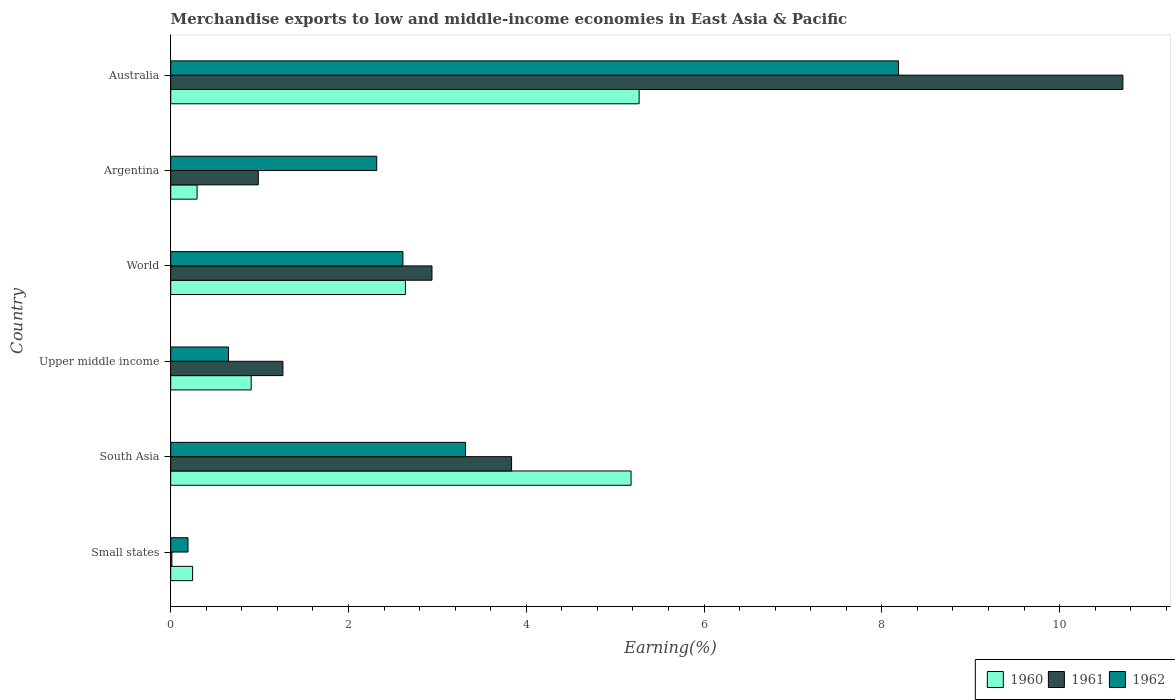How many different coloured bars are there?
Give a very brief answer. 3. How many groups of bars are there?
Offer a terse response. 6. Are the number of bars per tick equal to the number of legend labels?
Give a very brief answer. Yes. How many bars are there on the 2nd tick from the top?
Make the answer very short. 3. How many bars are there on the 3rd tick from the bottom?
Offer a terse response. 3. What is the label of the 6th group of bars from the top?
Provide a succinct answer. Small states. In how many cases, is the number of bars for a given country not equal to the number of legend labels?
Your answer should be very brief. 0. What is the percentage of amount earned from merchandise exports in 1961 in Small states?
Keep it short and to the point. 0.01. Across all countries, what is the maximum percentage of amount earned from merchandise exports in 1962?
Offer a very short reply. 8.19. Across all countries, what is the minimum percentage of amount earned from merchandise exports in 1962?
Ensure brevity in your answer.  0.19. In which country was the percentage of amount earned from merchandise exports in 1961 maximum?
Provide a succinct answer. Australia. In which country was the percentage of amount earned from merchandise exports in 1960 minimum?
Offer a very short reply. Small states. What is the total percentage of amount earned from merchandise exports in 1961 in the graph?
Your answer should be compact. 19.75. What is the difference between the percentage of amount earned from merchandise exports in 1961 in South Asia and that in Upper middle income?
Keep it short and to the point. 2.57. What is the difference between the percentage of amount earned from merchandise exports in 1961 in Upper middle income and the percentage of amount earned from merchandise exports in 1962 in Australia?
Your response must be concise. -6.93. What is the average percentage of amount earned from merchandise exports in 1961 per country?
Make the answer very short. 3.29. What is the difference between the percentage of amount earned from merchandise exports in 1960 and percentage of amount earned from merchandise exports in 1962 in Australia?
Your response must be concise. -2.92. In how many countries, is the percentage of amount earned from merchandise exports in 1961 greater than 5.6 %?
Make the answer very short. 1. What is the ratio of the percentage of amount earned from merchandise exports in 1960 in Argentina to that in Upper middle income?
Your answer should be compact. 0.33. Is the percentage of amount earned from merchandise exports in 1961 in South Asia less than that in World?
Ensure brevity in your answer.  No. What is the difference between the highest and the second highest percentage of amount earned from merchandise exports in 1962?
Provide a short and direct response. 4.87. What is the difference between the highest and the lowest percentage of amount earned from merchandise exports in 1961?
Keep it short and to the point. 10.7. Is it the case that in every country, the sum of the percentage of amount earned from merchandise exports in 1961 and percentage of amount earned from merchandise exports in 1960 is greater than the percentage of amount earned from merchandise exports in 1962?
Give a very brief answer. No. What is the difference between two consecutive major ticks on the X-axis?
Make the answer very short. 2. Where does the legend appear in the graph?
Make the answer very short. Bottom right. How many legend labels are there?
Provide a succinct answer. 3. How are the legend labels stacked?
Make the answer very short. Horizontal. What is the title of the graph?
Provide a short and direct response. Merchandise exports to low and middle-income economies in East Asia & Pacific. What is the label or title of the X-axis?
Provide a succinct answer. Earning(%). What is the label or title of the Y-axis?
Keep it short and to the point. Country. What is the Earning(%) of 1960 in Small states?
Give a very brief answer. 0.25. What is the Earning(%) of 1961 in Small states?
Provide a succinct answer. 0.01. What is the Earning(%) of 1962 in Small states?
Ensure brevity in your answer.  0.19. What is the Earning(%) of 1960 in South Asia?
Offer a terse response. 5.18. What is the Earning(%) of 1961 in South Asia?
Your answer should be compact. 3.83. What is the Earning(%) in 1962 in South Asia?
Provide a succinct answer. 3.32. What is the Earning(%) in 1960 in Upper middle income?
Your answer should be compact. 0.91. What is the Earning(%) of 1961 in Upper middle income?
Make the answer very short. 1.26. What is the Earning(%) in 1962 in Upper middle income?
Keep it short and to the point. 0.65. What is the Earning(%) of 1960 in World?
Keep it short and to the point. 2.64. What is the Earning(%) of 1961 in World?
Your answer should be very brief. 2.94. What is the Earning(%) in 1962 in World?
Keep it short and to the point. 2.61. What is the Earning(%) of 1960 in Argentina?
Provide a succinct answer. 0.3. What is the Earning(%) of 1961 in Argentina?
Provide a succinct answer. 0.99. What is the Earning(%) in 1962 in Argentina?
Offer a very short reply. 2.32. What is the Earning(%) of 1960 in Australia?
Your answer should be compact. 5.27. What is the Earning(%) in 1961 in Australia?
Offer a terse response. 10.71. What is the Earning(%) of 1962 in Australia?
Keep it short and to the point. 8.19. Across all countries, what is the maximum Earning(%) in 1960?
Ensure brevity in your answer.  5.27. Across all countries, what is the maximum Earning(%) of 1961?
Provide a short and direct response. 10.71. Across all countries, what is the maximum Earning(%) in 1962?
Your response must be concise. 8.19. Across all countries, what is the minimum Earning(%) in 1960?
Your answer should be compact. 0.25. Across all countries, what is the minimum Earning(%) in 1961?
Ensure brevity in your answer.  0.01. Across all countries, what is the minimum Earning(%) in 1962?
Your answer should be very brief. 0.19. What is the total Earning(%) of 1960 in the graph?
Provide a succinct answer. 14.54. What is the total Earning(%) in 1961 in the graph?
Offer a terse response. 19.75. What is the total Earning(%) of 1962 in the graph?
Your answer should be compact. 17.28. What is the difference between the Earning(%) in 1960 in Small states and that in South Asia?
Keep it short and to the point. -4.93. What is the difference between the Earning(%) of 1961 in Small states and that in South Asia?
Provide a succinct answer. -3.82. What is the difference between the Earning(%) of 1962 in Small states and that in South Asia?
Provide a short and direct response. -3.12. What is the difference between the Earning(%) in 1960 in Small states and that in Upper middle income?
Provide a short and direct response. -0.66. What is the difference between the Earning(%) in 1961 in Small states and that in Upper middle income?
Provide a succinct answer. -1.25. What is the difference between the Earning(%) in 1962 in Small states and that in Upper middle income?
Make the answer very short. -0.46. What is the difference between the Earning(%) of 1960 in Small states and that in World?
Offer a very short reply. -2.39. What is the difference between the Earning(%) in 1961 in Small states and that in World?
Your response must be concise. -2.93. What is the difference between the Earning(%) of 1962 in Small states and that in World?
Provide a succinct answer. -2.42. What is the difference between the Earning(%) of 1960 in Small states and that in Argentina?
Your answer should be very brief. -0.05. What is the difference between the Earning(%) in 1961 in Small states and that in Argentina?
Offer a terse response. -0.97. What is the difference between the Earning(%) of 1962 in Small states and that in Argentina?
Provide a succinct answer. -2.12. What is the difference between the Earning(%) in 1960 in Small states and that in Australia?
Offer a very short reply. -5.02. What is the difference between the Earning(%) in 1961 in Small states and that in Australia?
Give a very brief answer. -10.7. What is the difference between the Earning(%) of 1962 in Small states and that in Australia?
Ensure brevity in your answer.  -7.99. What is the difference between the Earning(%) in 1960 in South Asia and that in Upper middle income?
Keep it short and to the point. 4.27. What is the difference between the Earning(%) of 1961 in South Asia and that in Upper middle income?
Offer a very short reply. 2.57. What is the difference between the Earning(%) of 1962 in South Asia and that in Upper middle income?
Keep it short and to the point. 2.67. What is the difference between the Earning(%) of 1960 in South Asia and that in World?
Keep it short and to the point. 2.54. What is the difference between the Earning(%) in 1961 in South Asia and that in World?
Make the answer very short. 0.9. What is the difference between the Earning(%) in 1962 in South Asia and that in World?
Offer a terse response. 0.7. What is the difference between the Earning(%) of 1960 in South Asia and that in Argentina?
Your answer should be very brief. 4.88. What is the difference between the Earning(%) of 1961 in South Asia and that in Argentina?
Provide a succinct answer. 2.85. What is the difference between the Earning(%) in 1962 in South Asia and that in Argentina?
Your answer should be very brief. 1. What is the difference between the Earning(%) of 1960 in South Asia and that in Australia?
Give a very brief answer. -0.09. What is the difference between the Earning(%) in 1961 in South Asia and that in Australia?
Keep it short and to the point. -6.88. What is the difference between the Earning(%) of 1962 in South Asia and that in Australia?
Offer a terse response. -4.87. What is the difference between the Earning(%) of 1960 in Upper middle income and that in World?
Your answer should be compact. -1.74. What is the difference between the Earning(%) in 1961 in Upper middle income and that in World?
Your answer should be compact. -1.68. What is the difference between the Earning(%) in 1962 in Upper middle income and that in World?
Your answer should be very brief. -1.96. What is the difference between the Earning(%) in 1960 in Upper middle income and that in Argentina?
Your response must be concise. 0.61. What is the difference between the Earning(%) in 1961 in Upper middle income and that in Argentina?
Offer a terse response. 0.28. What is the difference between the Earning(%) of 1962 in Upper middle income and that in Argentina?
Provide a short and direct response. -1.67. What is the difference between the Earning(%) of 1960 in Upper middle income and that in Australia?
Your answer should be compact. -4.36. What is the difference between the Earning(%) of 1961 in Upper middle income and that in Australia?
Offer a very short reply. -9.45. What is the difference between the Earning(%) of 1962 in Upper middle income and that in Australia?
Provide a short and direct response. -7.54. What is the difference between the Earning(%) of 1960 in World and that in Argentina?
Provide a short and direct response. 2.34. What is the difference between the Earning(%) in 1961 in World and that in Argentina?
Your answer should be very brief. 1.95. What is the difference between the Earning(%) of 1962 in World and that in Argentina?
Your answer should be compact. 0.29. What is the difference between the Earning(%) in 1960 in World and that in Australia?
Offer a terse response. -2.63. What is the difference between the Earning(%) in 1961 in World and that in Australia?
Make the answer very short. -7.77. What is the difference between the Earning(%) of 1962 in World and that in Australia?
Offer a terse response. -5.58. What is the difference between the Earning(%) in 1960 in Argentina and that in Australia?
Make the answer very short. -4.97. What is the difference between the Earning(%) in 1961 in Argentina and that in Australia?
Your answer should be compact. -9.73. What is the difference between the Earning(%) in 1962 in Argentina and that in Australia?
Make the answer very short. -5.87. What is the difference between the Earning(%) in 1960 in Small states and the Earning(%) in 1961 in South Asia?
Keep it short and to the point. -3.59. What is the difference between the Earning(%) in 1960 in Small states and the Earning(%) in 1962 in South Asia?
Your answer should be very brief. -3.07. What is the difference between the Earning(%) of 1961 in Small states and the Earning(%) of 1962 in South Asia?
Offer a terse response. -3.3. What is the difference between the Earning(%) in 1960 in Small states and the Earning(%) in 1961 in Upper middle income?
Your answer should be very brief. -1.02. What is the difference between the Earning(%) of 1960 in Small states and the Earning(%) of 1962 in Upper middle income?
Your answer should be very brief. -0.4. What is the difference between the Earning(%) in 1961 in Small states and the Earning(%) in 1962 in Upper middle income?
Offer a terse response. -0.64. What is the difference between the Earning(%) of 1960 in Small states and the Earning(%) of 1961 in World?
Provide a short and direct response. -2.69. What is the difference between the Earning(%) in 1960 in Small states and the Earning(%) in 1962 in World?
Offer a terse response. -2.37. What is the difference between the Earning(%) in 1961 in Small states and the Earning(%) in 1962 in World?
Your answer should be very brief. -2.6. What is the difference between the Earning(%) in 1960 in Small states and the Earning(%) in 1961 in Argentina?
Ensure brevity in your answer.  -0.74. What is the difference between the Earning(%) in 1960 in Small states and the Earning(%) in 1962 in Argentina?
Your response must be concise. -2.07. What is the difference between the Earning(%) in 1961 in Small states and the Earning(%) in 1962 in Argentina?
Give a very brief answer. -2.3. What is the difference between the Earning(%) in 1960 in Small states and the Earning(%) in 1961 in Australia?
Your response must be concise. -10.47. What is the difference between the Earning(%) in 1960 in Small states and the Earning(%) in 1962 in Australia?
Offer a terse response. -7.94. What is the difference between the Earning(%) of 1961 in Small states and the Earning(%) of 1962 in Australia?
Your answer should be very brief. -8.18. What is the difference between the Earning(%) of 1960 in South Asia and the Earning(%) of 1961 in Upper middle income?
Offer a very short reply. 3.92. What is the difference between the Earning(%) in 1960 in South Asia and the Earning(%) in 1962 in Upper middle income?
Offer a terse response. 4.53. What is the difference between the Earning(%) of 1961 in South Asia and the Earning(%) of 1962 in Upper middle income?
Give a very brief answer. 3.18. What is the difference between the Earning(%) in 1960 in South Asia and the Earning(%) in 1961 in World?
Your response must be concise. 2.24. What is the difference between the Earning(%) in 1960 in South Asia and the Earning(%) in 1962 in World?
Offer a terse response. 2.57. What is the difference between the Earning(%) in 1961 in South Asia and the Earning(%) in 1962 in World?
Offer a very short reply. 1.22. What is the difference between the Earning(%) of 1960 in South Asia and the Earning(%) of 1961 in Argentina?
Your answer should be very brief. 4.19. What is the difference between the Earning(%) of 1960 in South Asia and the Earning(%) of 1962 in Argentina?
Provide a succinct answer. 2.86. What is the difference between the Earning(%) in 1961 in South Asia and the Earning(%) in 1962 in Argentina?
Your answer should be very brief. 1.52. What is the difference between the Earning(%) in 1960 in South Asia and the Earning(%) in 1961 in Australia?
Your answer should be very brief. -5.53. What is the difference between the Earning(%) in 1960 in South Asia and the Earning(%) in 1962 in Australia?
Ensure brevity in your answer.  -3.01. What is the difference between the Earning(%) in 1961 in South Asia and the Earning(%) in 1962 in Australia?
Ensure brevity in your answer.  -4.35. What is the difference between the Earning(%) in 1960 in Upper middle income and the Earning(%) in 1961 in World?
Offer a terse response. -2.03. What is the difference between the Earning(%) in 1960 in Upper middle income and the Earning(%) in 1962 in World?
Offer a terse response. -1.71. What is the difference between the Earning(%) in 1961 in Upper middle income and the Earning(%) in 1962 in World?
Ensure brevity in your answer.  -1.35. What is the difference between the Earning(%) of 1960 in Upper middle income and the Earning(%) of 1961 in Argentina?
Offer a terse response. -0.08. What is the difference between the Earning(%) of 1960 in Upper middle income and the Earning(%) of 1962 in Argentina?
Your response must be concise. -1.41. What is the difference between the Earning(%) of 1961 in Upper middle income and the Earning(%) of 1962 in Argentina?
Your answer should be compact. -1.06. What is the difference between the Earning(%) of 1960 in Upper middle income and the Earning(%) of 1961 in Australia?
Give a very brief answer. -9.81. What is the difference between the Earning(%) of 1960 in Upper middle income and the Earning(%) of 1962 in Australia?
Provide a short and direct response. -7.28. What is the difference between the Earning(%) in 1961 in Upper middle income and the Earning(%) in 1962 in Australia?
Ensure brevity in your answer.  -6.93. What is the difference between the Earning(%) in 1960 in World and the Earning(%) in 1961 in Argentina?
Ensure brevity in your answer.  1.66. What is the difference between the Earning(%) in 1960 in World and the Earning(%) in 1962 in Argentina?
Ensure brevity in your answer.  0.32. What is the difference between the Earning(%) in 1961 in World and the Earning(%) in 1962 in Argentina?
Offer a terse response. 0.62. What is the difference between the Earning(%) of 1960 in World and the Earning(%) of 1961 in Australia?
Keep it short and to the point. -8.07. What is the difference between the Earning(%) of 1960 in World and the Earning(%) of 1962 in Australia?
Your response must be concise. -5.55. What is the difference between the Earning(%) in 1961 in World and the Earning(%) in 1962 in Australia?
Provide a short and direct response. -5.25. What is the difference between the Earning(%) in 1960 in Argentina and the Earning(%) in 1961 in Australia?
Your answer should be compact. -10.42. What is the difference between the Earning(%) of 1960 in Argentina and the Earning(%) of 1962 in Australia?
Ensure brevity in your answer.  -7.89. What is the difference between the Earning(%) of 1961 in Argentina and the Earning(%) of 1962 in Australia?
Provide a short and direct response. -7.2. What is the average Earning(%) in 1960 per country?
Your answer should be compact. 2.42. What is the average Earning(%) in 1961 per country?
Your response must be concise. 3.29. What is the average Earning(%) in 1962 per country?
Give a very brief answer. 2.88. What is the difference between the Earning(%) of 1960 and Earning(%) of 1961 in Small states?
Provide a short and direct response. 0.23. What is the difference between the Earning(%) of 1960 and Earning(%) of 1962 in Small states?
Provide a short and direct response. 0.05. What is the difference between the Earning(%) of 1961 and Earning(%) of 1962 in Small states?
Offer a very short reply. -0.18. What is the difference between the Earning(%) of 1960 and Earning(%) of 1961 in South Asia?
Your answer should be compact. 1.34. What is the difference between the Earning(%) of 1960 and Earning(%) of 1962 in South Asia?
Keep it short and to the point. 1.86. What is the difference between the Earning(%) in 1961 and Earning(%) in 1962 in South Asia?
Ensure brevity in your answer.  0.52. What is the difference between the Earning(%) in 1960 and Earning(%) in 1961 in Upper middle income?
Ensure brevity in your answer.  -0.36. What is the difference between the Earning(%) in 1960 and Earning(%) in 1962 in Upper middle income?
Your answer should be very brief. 0.26. What is the difference between the Earning(%) of 1961 and Earning(%) of 1962 in Upper middle income?
Provide a short and direct response. 0.61. What is the difference between the Earning(%) in 1960 and Earning(%) in 1961 in World?
Make the answer very short. -0.3. What is the difference between the Earning(%) in 1960 and Earning(%) in 1962 in World?
Your response must be concise. 0.03. What is the difference between the Earning(%) of 1961 and Earning(%) of 1962 in World?
Offer a very short reply. 0.33. What is the difference between the Earning(%) in 1960 and Earning(%) in 1961 in Argentina?
Give a very brief answer. -0.69. What is the difference between the Earning(%) of 1960 and Earning(%) of 1962 in Argentina?
Offer a terse response. -2.02. What is the difference between the Earning(%) of 1961 and Earning(%) of 1962 in Argentina?
Ensure brevity in your answer.  -1.33. What is the difference between the Earning(%) in 1960 and Earning(%) in 1961 in Australia?
Provide a short and direct response. -5.44. What is the difference between the Earning(%) of 1960 and Earning(%) of 1962 in Australia?
Your answer should be very brief. -2.92. What is the difference between the Earning(%) in 1961 and Earning(%) in 1962 in Australia?
Offer a terse response. 2.52. What is the ratio of the Earning(%) in 1960 in Small states to that in South Asia?
Provide a short and direct response. 0.05. What is the ratio of the Earning(%) in 1961 in Small states to that in South Asia?
Your answer should be very brief. 0. What is the ratio of the Earning(%) in 1962 in Small states to that in South Asia?
Give a very brief answer. 0.06. What is the ratio of the Earning(%) in 1960 in Small states to that in Upper middle income?
Offer a very short reply. 0.27. What is the ratio of the Earning(%) in 1961 in Small states to that in Upper middle income?
Keep it short and to the point. 0.01. What is the ratio of the Earning(%) in 1962 in Small states to that in Upper middle income?
Make the answer very short. 0.3. What is the ratio of the Earning(%) of 1960 in Small states to that in World?
Your response must be concise. 0.09. What is the ratio of the Earning(%) of 1961 in Small states to that in World?
Give a very brief answer. 0. What is the ratio of the Earning(%) of 1962 in Small states to that in World?
Offer a terse response. 0.07. What is the ratio of the Earning(%) of 1960 in Small states to that in Argentina?
Keep it short and to the point. 0.83. What is the ratio of the Earning(%) of 1961 in Small states to that in Argentina?
Make the answer very short. 0.01. What is the ratio of the Earning(%) of 1962 in Small states to that in Argentina?
Offer a terse response. 0.08. What is the ratio of the Earning(%) of 1960 in Small states to that in Australia?
Give a very brief answer. 0.05. What is the ratio of the Earning(%) in 1961 in Small states to that in Australia?
Offer a very short reply. 0. What is the ratio of the Earning(%) of 1962 in Small states to that in Australia?
Provide a short and direct response. 0.02. What is the ratio of the Earning(%) in 1960 in South Asia to that in Upper middle income?
Keep it short and to the point. 5.72. What is the ratio of the Earning(%) of 1961 in South Asia to that in Upper middle income?
Offer a terse response. 3.04. What is the ratio of the Earning(%) in 1962 in South Asia to that in Upper middle income?
Your answer should be very brief. 5.1. What is the ratio of the Earning(%) in 1960 in South Asia to that in World?
Offer a very short reply. 1.96. What is the ratio of the Earning(%) in 1961 in South Asia to that in World?
Make the answer very short. 1.3. What is the ratio of the Earning(%) in 1962 in South Asia to that in World?
Your answer should be compact. 1.27. What is the ratio of the Earning(%) in 1960 in South Asia to that in Argentina?
Offer a terse response. 17.46. What is the ratio of the Earning(%) in 1961 in South Asia to that in Argentina?
Your answer should be very brief. 3.89. What is the ratio of the Earning(%) of 1962 in South Asia to that in Argentina?
Offer a terse response. 1.43. What is the ratio of the Earning(%) in 1960 in South Asia to that in Australia?
Make the answer very short. 0.98. What is the ratio of the Earning(%) of 1961 in South Asia to that in Australia?
Ensure brevity in your answer.  0.36. What is the ratio of the Earning(%) of 1962 in South Asia to that in Australia?
Offer a terse response. 0.41. What is the ratio of the Earning(%) in 1960 in Upper middle income to that in World?
Provide a succinct answer. 0.34. What is the ratio of the Earning(%) of 1961 in Upper middle income to that in World?
Ensure brevity in your answer.  0.43. What is the ratio of the Earning(%) in 1962 in Upper middle income to that in World?
Your answer should be very brief. 0.25. What is the ratio of the Earning(%) of 1960 in Upper middle income to that in Argentina?
Provide a succinct answer. 3.05. What is the ratio of the Earning(%) in 1961 in Upper middle income to that in Argentina?
Provide a succinct answer. 1.28. What is the ratio of the Earning(%) in 1962 in Upper middle income to that in Argentina?
Provide a short and direct response. 0.28. What is the ratio of the Earning(%) of 1960 in Upper middle income to that in Australia?
Make the answer very short. 0.17. What is the ratio of the Earning(%) in 1961 in Upper middle income to that in Australia?
Your response must be concise. 0.12. What is the ratio of the Earning(%) of 1962 in Upper middle income to that in Australia?
Offer a very short reply. 0.08. What is the ratio of the Earning(%) of 1960 in World to that in Argentina?
Ensure brevity in your answer.  8.9. What is the ratio of the Earning(%) of 1961 in World to that in Argentina?
Keep it short and to the point. 2.98. What is the ratio of the Earning(%) in 1962 in World to that in Argentina?
Provide a succinct answer. 1.13. What is the ratio of the Earning(%) of 1960 in World to that in Australia?
Offer a terse response. 0.5. What is the ratio of the Earning(%) in 1961 in World to that in Australia?
Your response must be concise. 0.27. What is the ratio of the Earning(%) of 1962 in World to that in Australia?
Provide a short and direct response. 0.32. What is the ratio of the Earning(%) in 1960 in Argentina to that in Australia?
Offer a terse response. 0.06. What is the ratio of the Earning(%) in 1961 in Argentina to that in Australia?
Offer a very short reply. 0.09. What is the ratio of the Earning(%) in 1962 in Argentina to that in Australia?
Ensure brevity in your answer.  0.28. What is the difference between the highest and the second highest Earning(%) in 1960?
Provide a short and direct response. 0.09. What is the difference between the highest and the second highest Earning(%) in 1961?
Your answer should be compact. 6.88. What is the difference between the highest and the second highest Earning(%) of 1962?
Your response must be concise. 4.87. What is the difference between the highest and the lowest Earning(%) in 1960?
Your response must be concise. 5.02. What is the difference between the highest and the lowest Earning(%) in 1961?
Provide a succinct answer. 10.7. What is the difference between the highest and the lowest Earning(%) of 1962?
Provide a short and direct response. 7.99. 